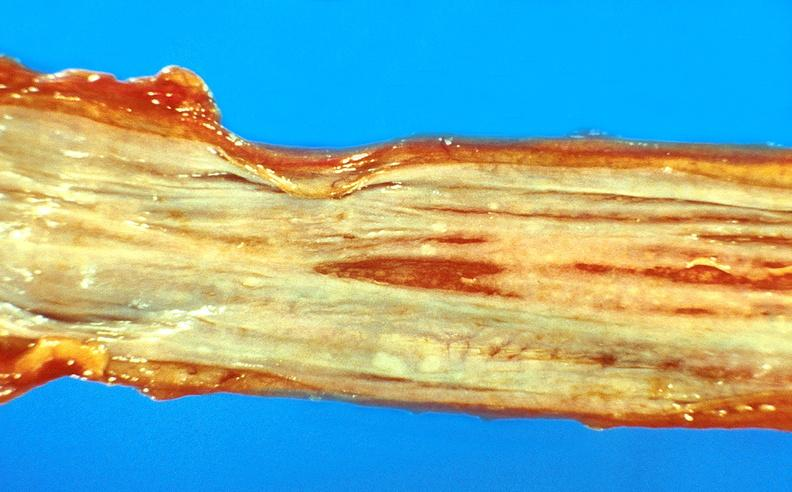does this image show esophageal varices?
Answer the question using a single word or phrase. Yes 